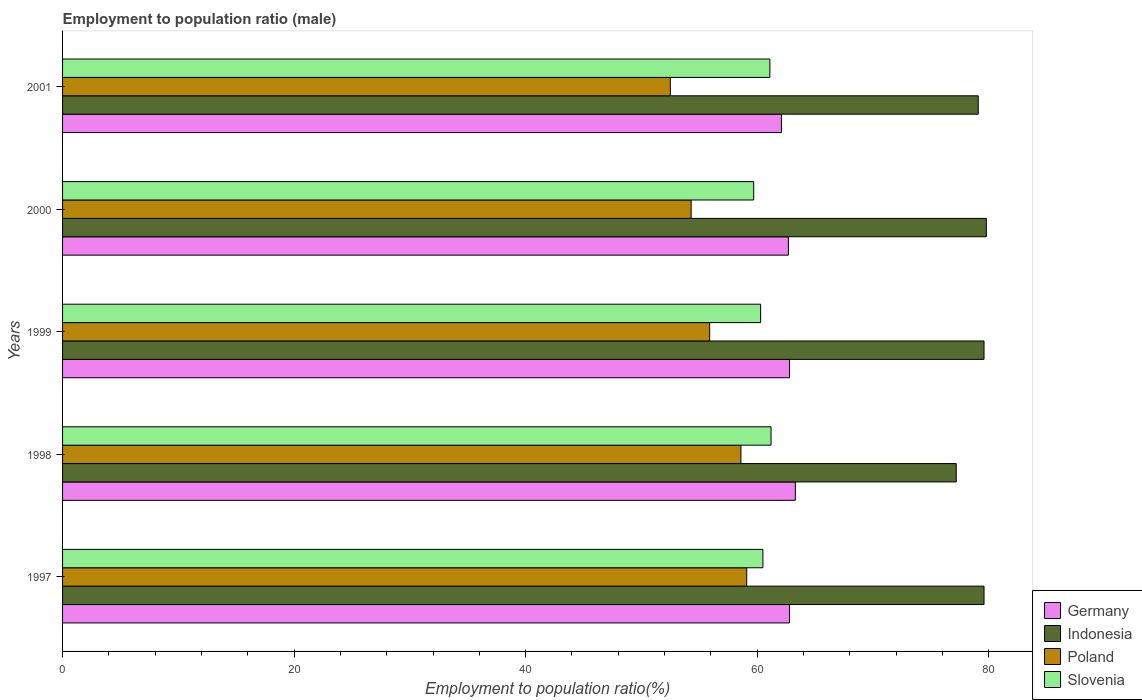How many different coloured bars are there?
Provide a short and direct response. 4. What is the label of the 2nd group of bars from the top?
Provide a short and direct response. 2000. In how many cases, is the number of bars for a given year not equal to the number of legend labels?
Give a very brief answer. 0. What is the employment to population ratio in Germany in 1997?
Your response must be concise. 62.8. Across all years, what is the maximum employment to population ratio in Germany?
Provide a short and direct response. 63.3. Across all years, what is the minimum employment to population ratio in Poland?
Your answer should be compact. 52.5. In which year was the employment to population ratio in Slovenia maximum?
Offer a terse response. 1998. What is the total employment to population ratio in Germany in the graph?
Keep it short and to the point. 313.7. What is the difference between the employment to population ratio in Indonesia in 1998 and that in 2000?
Offer a very short reply. -2.6. What is the difference between the employment to population ratio in Indonesia in 2000 and the employment to population ratio in Germany in 1997?
Your response must be concise. 17. What is the average employment to population ratio in Poland per year?
Keep it short and to the point. 56.08. In the year 2000, what is the difference between the employment to population ratio in Slovenia and employment to population ratio in Germany?
Ensure brevity in your answer.  -3. What is the ratio of the employment to population ratio in Germany in 1997 to that in 2001?
Your answer should be compact. 1.01. Is the difference between the employment to population ratio in Slovenia in 1997 and 1998 greater than the difference between the employment to population ratio in Germany in 1997 and 1998?
Give a very brief answer. No. What is the difference between the highest and the second highest employment to population ratio in Indonesia?
Your answer should be very brief. 0.2. What is the difference between the highest and the lowest employment to population ratio in Poland?
Offer a very short reply. 6.6. Is the sum of the employment to population ratio in Poland in 1998 and 1999 greater than the maximum employment to population ratio in Indonesia across all years?
Ensure brevity in your answer.  Yes. What does the 1st bar from the top in 1997 represents?
Keep it short and to the point. Slovenia. What does the 1st bar from the bottom in 2000 represents?
Give a very brief answer. Germany. Is it the case that in every year, the sum of the employment to population ratio in Poland and employment to population ratio in Slovenia is greater than the employment to population ratio in Germany?
Make the answer very short. Yes. How many bars are there?
Give a very brief answer. 20. What is the difference between two consecutive major ticks on the X-axis?
Provide a succinct answer. 20. Does the graph contain grids?
Provide a short and direct response. No. Where does the legend appear in the graph?
Ensure brevity in your answer.  Bottom right. How many legend labels are there?
Your answer should be compact. 4. How are the legend labels stacked?
Provide a short and direct response. Vertical. What is the title of the graph?
Your answer should be very brief. Employment to population ratio (male). What is the label or title of the Y-axis?
Make the answer very short. Years. What is the Employment to population ratio(%) of Germany in 1997?
Give a very brief answer. 62.8. What is the Employment to population ratio(%) in Indonesia in 1997?
Provide a succinct answer. 79.6. What is the Employment to population ratio(%) in Poland in 1997?
Your response must be concise. 59.1. What is the Employment to population ratio(%) of Slovenia in 1997?
Ensure brevity in your answer.  60.5. What is the Employment to population ratio(%) of Germany in 1998?
Keep it short and to the point. 63.3. What is the Employment to population ratio(%) of Indonesia in 1998?
Make the answer very short. 77.2. What is the Employment to population ratio(%) of Poland in 1998?
Give a very brief answer. 58.6. What is the Employment to population ratio(%) in Slovenia in 1998?
Offer a terse response. 61.2. What is the Employment to population ratio(%) of Germany in 1999?
Your answer should be very brief. 62.8. What is the Employment to population ratio(%) in Indonesia in 1999?
Your response must be concise. 79.6. What is the Employment to population ratio(%) in Poland in 1999?
Give a very brief answer. 55.9. What is the Employment to population ratio(%) in Slovenia in 1999?
Ensure brevity in your answer.  60.3. What is the Employment to population ratio(%) of Germany in 2000?
Give a very brief answer. 62.7. What is the Employment to population ratio(%) in Indonesia in 2000?
Your response must be concise. 79.8. What is the Employment to population ratio(%) in Poland in 2000?
Give a very brief answer. 54.3. What is the Employment to population ratio(%) of Slovenia in 2000?
Offer a very short reply. 59.7. What is the Employment to population ratio(%) of Germany in 2001?
Keep it short and to the point. 62.1. What is the Employment to population ratio(%) of Indonesia in 2001?
Provide a succinct answer. 79.1. What is the Employment to population ratio(%) in Poland in 2001?
Keep it short and to the point. 52.5. What is the Employment to population ratio(%) of Slovenia in 2001?
Your answer should be compact. 61.1. Across all years, what is the maximum Employment to population ratio(%) of Germany?
Ensure brevity in your answer.  63.3. Across all years, what is the maximum Employment to population ratio(%) in Indonesia?
Your response must be concise. 79.8. Across all years, what is the maximum Employment to population ratio(%) of Poland?
Give a very brief answer. 59.1. Across all years, what is the maximum Employment to population ratio(%) in Slovenia?
Your answer should be very brief. 61.2. Across all years, what is the minimum Employment to population ratio(%) in Germany?
Ensure brevity in your answer.  62.1. Across all years, what is the minimum Employment to population ratio(%) of Indonesia?
Give a very brief answer. 77.2. Across all years, what is the minimum Employment to population ratio(%) in Poland?
Your response must be concise. 52.5. Across all years, what is the minimum Employment to population ratio(%) of Slovenia?
Make the answer very short. 59.7. What is the total Employment to population ratio(%) in Germany in the graph?
Your answer should be very brief. 313.7. What is the total Employment to population ratio(%) in Indonesia in the graph?
Ensure brevity in your answer.  395.3. What is the total Employment to population ratio(%) of Poland in the graph?
Your response must be concise. 280.4. What is the total Employment to population ratio(%) in Slovenia in the graph?
Make the answer very short. 302.8. What is the difference between the Employment to population ratio(%) of Germany in 1997 and that in 1998?
Make the answer very short. -0.5. What is the difference between the Employment to population ratio(%) of Indonesia in 1997 and that in 1998?
Give a very brief answer. 2.4. What is the difference between the Employment to population ratio(%) of Indonesia in 1997 and that in 1999?
Give a very brief answer. 0. What is the difference between the Employment to population ratio(%) of Poland in 1997 and that in 1999?
Keep it short and to the point. 3.2. What is the difference between the Employment to population ratio(%) of Slovenia in 1997 and that in 2000?
Your answer should be compact. 0.8. What is the difference between the Employment to population ratio(%) of Germany in 1998 and that in 1999?
Provide a short and direct response. 0.5. What is the difference between the Employment to population ratio(%) of Indonesia in 1998 and that in 1999?
Provide a succinct answer. -2.4. What is the difference between the Employment to population ratio(%) of Poland in 1998 and that in 1999?
Keep it short and to the point. 2.7. What is the difference between the Employment to population ratio(%) of Slovenia in 1998 and that in 1999?
Your response must be concise. 0.9. What is the difference between the Employment to population ratio(%) in Slovenia in 1998 and that in 2000?
Offer a terse response. 1.5. What is the difference between the Employment to population ratio(%) of Indonesia in 1998 and that in 2001?
Make the answer very short. -1.9. What is the difference between the Employment to population ratio(%) of Indonesia in 1999 and that in 2000?
Your answer should be very brief. -0.2. What is the difference between the Employment to population ratio(%) in Germany in 1999 and that in 2001?
Make the answer very short. 0.7. What is the difference between the Employment to population ratio(%) in Indonesia in 1999 and that in 2001?
Give a very brief answer. 0.5. What is the difference between the Employment to population ratio(%) in Poland in 1999 and that in 2001?
Offer a very short reply. 3.4. What is the difference between the Employment to population ratio(%) in Slovenia in 1999 and that in 2001?
Provide a succinct answer. -0.8. What is the difference between the Employment to population ratio(%) in Germany in 2000 and that in 2001?
Ensure brevity in your answer.  0.6. What is the difference between the Employment to population ratio(%) in Indonesia in 2000 and that in 2001?
Your answer should be compact. 0.7. What is the difference between the Employment to population ratio(%) in Slovenia in 2000 and that in 2001?
Provide a succinct answer. -1.4. What is the difference between the Employment to population ratio(%) of Germany in 1997 and the Employment to population ratio(%) of Indonesia in 1998?
Make the answer very short. -14.4. What is the difference between the Employment to population ratio(%) in Germany in 1997 and the Employment to population ratio(%) in Poland in 1998?
Give a very brief answer. 4.2. What is the difference between the Employment to population ratio(%) in Poland in 1997 and the Employment to population ratio(%) in Slovenia in 1998?
Ensure brevity in your answer.  -2.1. What is the difference between the Employment to population ratio(%) of Germany in 1997 and the Employment to population ratio(%) of Indonesia in 1999?
Give a very brief answer. -16.8. What is the difference between the Employment to population ratio(%) in Germany in 1997 and the Employment to population ratio(%) in Poland in 1999?
Keep it short and to the point. 6.9. What is the difference between the Employment to population ratio(%) in Indonesia in 1997 and the Employment to population ratio(%) in Poland in 1999?
Offer a terse response. 23.7. What is the difference between the Employment to population ratio(%) of Indonesia in 1997 and the Employment to population ratio(%) of Slovenia in 1999?
Make the answer very short. 19.3. What is the difference between the Employment to population ratio(%) in Germany in 1997 and the Employment to population ratio(%) in Poland in 2000?
Give a very brief answer. 8.5. What is the difference between the Employment to population ratio(%) of Germany in 1997 and the Employment to population ratio(%) of Slovenia in 2000?
Your response must be concise. 3.1. What is the difference between the Employment to population ratio(%) in Indonesia in 1997 and the Employment to population ratio(%) in Poland in 2000?
Ensure brevity in your answer.  25.3. What is the difference between the Employment to population ratio(%) in Poland in 1997 and the Employment to population ratio(%) in Slovenia in 2000?
Keep it short and to the point. -0.6. What is the difference between the Employment to population ratio(%) in Germany in 1997 and the Employment to population ratio(%) in Indonesia in 2001?
Ensure brevity in your answer.  -16.3. What is the difference between the Employment to population ratio(%) of Germany in 1997 and the Employment to population ratio(%) of Poland in 2001?
Your answer should be very brief. 10.3. What is the difference between the Employment to population ratio(%) in Indonesia in 1997 and the Employment to population ratio(%) in Poland in 2001?
Ensure brevity in your answer.  27.1. What is the difference between the Employment to population ratio(%) in Germany in 1998 and the Employment to population ratio(%) in Indonesia in 1999?
Provide a succinct answer. -16.3. What is the difference between the Employment to population ratio(%) in Germany in 1998 and the Employment to population ratio(%) in Poland in 1999?
Offer a very short reply. 7.4. What is the difference between the Employment to population ratio(%) of Indonesia in 1998 and the Employment to population ratio(%) of Poland in 1999?
Offer a very short reply. 21.3. What is the difference between the Employment to population ratio(%) of Indonesia in 1998 and the Employment to population ratio(%) of Slovenia in 1999?
Your response must be concise. 16.9. What is the difference between the Employment to population ratio(%) of Germany in 1998 and the Employment to population ratio(%) of Indonesia in 2000?
Give a very brief answer. -16.5. What is the difference between the Employment to population ratio(%) of Germany in 1998 and the Employment to population ratio(%) of Poland in 2000?
Offer a terse response. 9. What is the difference between the Employment to population ratio(%) of Indonesia in 1998 and the Employment to population ratio(%) of Poland in 2000?
Give a very brief answer. 22.9. What is the difference between the Employment to population ratio(%) of Germany in 1998 and the Employment to population ratio(%) of Indonesia in 2001?
Offer a terse response. -15.8. What is the difference between the Employment to population ratio(%) in Germany in 1998 and the Employment to population ratio(%) in Poland in 2001?
Your answer should be compact. 10.8. What is the difference between the Employment to population ratio(%) of Indonesia in 1998 and the Employment to population ratio(%) of Poland in 2001?
Your answer should be very brief. 24.7. What is the difference between the Employment to population ratio(%) in Indonesia in 1998 and the Employment to population ratio(%) in Slovenia in 2001?
Offer a terse response. 16.1. What is the difference between the Employment to population ratio(%) of Poland in 1998 and the Employment to population ratio(%) of Slovenia in 2001?
Offer a terse response. -2.5. What is the difference between the Employment to population ratio(%) in Germany in 1999 and the Employment to population ratio(%) in Poland in 2000?
Offer a very short reply. 8.5. What is the difference between the Employment to population ratio(%) in Germany in 1999 and the Employment to population ratio(%) in Slovenia in 2000?
Ensure brevity in your answer.  3.1. What is the difference between the Employment to population ratio(%) in Indonesia in 1999 and the Employment to population ratio(%) in Poland in 2000?
Make the answer very short. 25.3. What is the difference between the Employment to population ratio(%) in Germany in 1999 and the Employment to population ratio(%) in Indonesia in 2001?
Ensure brevity in your answer.  -16.3. What is the difference between the Employment to population ratio(%) of Germany in 1999 and the Employment to population ratio(%) of Poland in 2001?
Your answer should be compact. 10.3. What is the difference between the Employment to population ratio(%) in Germany in 1999 and the Employment to population ratio(%) in Slovenia in 2001?
Provide a short and direct response. 1.7. What is the difference between the Employment to population ratio(%) of Indonesia in 1999 and the Employment to population ratio(%) of Poland in 2001?
Your response must be concise. 27.1. What is the difference between the Employment to population ratio(%) of Poland in 1999 and the Employment to population ratio(%) of Slovenia in 2001?
Offer a very short reply. -5.2. What is the difference between the Employment to population ratio(%) of Germany in 2000 and the Employment to population ratio(%) of Indonesia in 2001?
Provide a succinct answer. -16.4. What is the difference between the Employment to population ratio(%) in Germany in 2000 and the Employment to population ratio(%) in Poland in 2001?
Keep it short and to the point. 10.2. What is the difference between the Employment to population ratio(%) of Indonesia in 2000 and the Employment to population ratio(%) of Poland in 2001?
Offer a very short reply. 27.3. What is the difference between the Employment to population ratio(%) of Indonesia in 2000 and the Employment to population ratio(%) of Slovenia in 2001?
Your response must be concise. 18.7. What is the average Employment to population ratio(%) in Germany per year?
Offer a very short reply. 62.74. What is the average Employment to population ratio(%) in Indonesia per year?
Offer a very short reply. 79.06. What is the average Employment to population ratio(%) in Poland per year?
Your answer should be compact. 56.08. What is the average Employment to population ratio(%) in Slovenia per year?
Offer a terse response. 60.56. In the year 1997, what is the difference between the Employment to population ratio(%) of Germany and Employment to population ratio(%) of Indonesia?
Give a very brief answer. -16.8. In the year 1997, what is the difference between the Employment to population ratio(%) of Indonesia and Employment to population ratio(%) of Slovenia?
Your response must be concise. 19.1. In the year 1997, what is the difference between the Employment to population ratio(%) in Poland and Employment to population ratio(%) in Slovenia?
Offer a very short reply. -1.4. In the year 1998, what is the difference between the Employment to population ratio(%) of Indonesia and Employment to population ratio(%) of Poland?
Make the answer very short. 18.6. In the year 1998, what is the difference between the Employment to population ratio(%) of Poland and Employment to population ratio(%) of Slovenia?
Your answer should be compact. -2.6. In the year 1999, what is the difference between the Employment to population ratio(%) of Germany and Employment to population ratio(%) of Indonesia?
Your response must be concise. -16.8. In the year 1999, what is the difference between the Employment to population ratio(%) of Germany and Employment to population ratio(%) of Poland?
Provide a succinct answer. 6.9. In the year 1999, what is the difference between the Employment to population ratio(%) of Indonesia and Employment to population ratio(%) of Poland?
Provide a short and direct response. 23.7. In the year 1999, what is the difference between the Employment to population ratio(%) in Indonesia and Employment to population ratio(%) in Slovenia?
Offer a terse response. 19.3. In the year 1999, what is the difference between the Employment to population ratio(%) of Poland and Employment to population ratio(%) of Slovenia?
Make the answer very short. -4.4. In the year 2000, what is the difference between the Employment to population ratio(%) in Germany and Employment to population ratio(%) in Indonesia?
Your answer should be very brief. -17.1. In the year 2000, what is the difference between the Employment to population ratio(%) of Germany and Employment to population ratio(%) of Poland?
Your answer should be very brief. 8.4. In the year 2000, what is the difference between the Employment to population ratio(%) in Indonesia and Employment to population ratio(%) in Poland?
Provide a succinct answer. 25.5. In the year 2000, what is the difference between the Employment to population ratio(%) of Indonesia and Employment to population ratio(%) of Slovenia?
Offer a terse response. 20.1. In the year 2001, what is the difference between the Employment to population ratio(%) in Germany and Employment to population ratio(%) in Poland?
Keep it short and to the point. 9.6. In the year 2001, what is the difference between the Employment to population ratio(%) of Indonesia and Employment to population ratio(%) of Poland?
Give a very brief answer. 26.6. In the year 2001, what is the difference between the Employment to population ratio(%) in Indonesia and Employment to population ratio(%) in Slovenia?
Make the answer very short. 18. In the year 2001, what is the difference between the Employment to population ratio(%) in Poland and Employment to population ratio(%) in Slovenia?
Keep it short and to the point. -8.6. What is the ratio of the Employment to population ratio(%) in Indonesia in 1997 to that in 1998?
Give a very brief answer. 1.03. What is the ratio of the Employment to population ratio(%) of Poland in 1997 to that in 1998?
Your answer should be very brief. 1.01. What is the ratio of the Employment to population ratio(%) in Poland in 1997 to that in 1999?
Offer a terse response. 1.06. What is the ratio of the Employment to population ratio(%) in Slovenia in 1997 to that in 1999?
Ensure brevity in your answer.  1. What is the ratio of the Employment to population ratio(%) in Germany in 1997 to that in 2000?
Offer a terse response. 1. What is the ratio of the Employment to population ratio(%) in Poland in 1997 to that in 2000?
Offer a very short reply. 1.09. What is the ratio of the Employment to population ratio(%) of Slovenia in 1997 to that in 2000?
Make the answer very short. 1.01. What is the ratio of the Employment to population ratio(%) of Germany in 1997 to that in 2001?
Give a very brief answer. 1.01. What is the ratio of the Employment to population ratio(%) in Indonesia in 1997 to that in 2001?
Offer a very short reply. 1.01. What is the ratio of the Employment to population ratio(%) of Poland in 1997 to that in 2001?
Your answer should be very brief. 1.13. What is the ratio of the Employment to population ratio(%) in Slovenia in 1997 to that in 2001?
Your answer should be very brief. 0.99. What is the ratio of the Employment to population ratio(%) of Germany in 1998 to that in 1999?
Your answer should be very brief. 1.01. What is the ratio of the Employment to population ratio(%) in Indonesia in 1998 to that in 1999?
Your answer should be very brief. 0.97. What is the ratio of the Employment to population ratio(%) in Poland in 1998 to that in 1999?
Your answer should be very brief. 1.05. What is the ratio of the Employment to population ratio(%) in Slovenia in 1998 to that in 1999?
Give a very brief answer. 1.01. What is the ratio of the Employment to population ratio(%) in Germany in 1998 to that in 2000?
Ensure brevity in your answer.  1.01. What is the ratio of the Employment to population ratio(%) of Indonesia in 1998 to that in 2000?
Ensure brevity in your answer.  0.97. What is the ratio of the Employment to population ratio(%) of Poland in 1998 to that in 2000?
Make the answer very short. 1.08. What is the ratio of the Employment to population ratio(%) in Slovenia in 1998 to that in 2000?
Give a very brief answer. 1.03. What is the ratio of the Employment to population ratio(%) in Germany in 1998 to that in 2001?
Make the answer very short. 1.02. What is the ratio of the Employment to population ratio(%) in Indonesia in 1998 to that in 2001?
Keep it short and to the point. 0.98. What is the ratio of the Employment to population ratio(%) of Poland in 1998 to that in 2001?
Ensure brevity in your answer.  1.12. What is the ratio of the Employment to population ratio(%) in Slovenia in 1998 to that in 2001?
Your answer should be compact. 1. What is the ratio of the Employment to population ratio(%) of Poland in 1999 to that in 2000?
Ensure brevity in your answer.  1.03. What is the ratio of the Employment to population ratio(%) in Slovenia in 1999 to that in 2000?
Provide a succinct answer. 1.01. What is the ratio of the Employment to population ratio(%) in Germany in 1999 to that in 2001?
Offer a terse response. 1.01. What is the ratio of the Employment to population ratio(%) of Poland in 1999 to that in 2001?
Give a very brief answer. 1.06. What is the ratio of the Employment to population ratio(%) in Slovenia in 1999 to that in 2001?
Your answer should be very brief. 0.99. What is the ratio of the Employment to population ratio(%) in Germany in 2000 to that in 2001?
Offer a terse response. 1.01. What is the ratio of the Employment to population ratio(%) of Indonesia in 2000 to that in 2001?
Your answer should be very brief. 1.01. What is the ratio of the Employment to population ratio(%) of Poland in 2000 to that in 2001?
Your answer should be very brief. 1.03. What is the ratio of the Employment to population ratio(%) of Slovenia in 2000 to that in 2001?
Offer a very short reply. 0.98. What is the difference between the highest and the second highest Employment to population ratio(%) of Indonesia?
Offer a very short reply. 0.2. What is the difference between the highest and the second highest Employment to population ratio(%) in Slovenia?
Ensure brevity in your answer.  0.1. What is the difference between the highest and the lowest Employment to population ratio(%) in Germany?
Make the answer very short. 1.2. What is the difference between the highest and the lowest Employment to population ratio(%) of Indonesia?
Your answer should be very brief. 2.6. What is the difference between the highest and the lowest Employment to population ratio(%) in Poland?
Give a very brief answer. 6.6. 